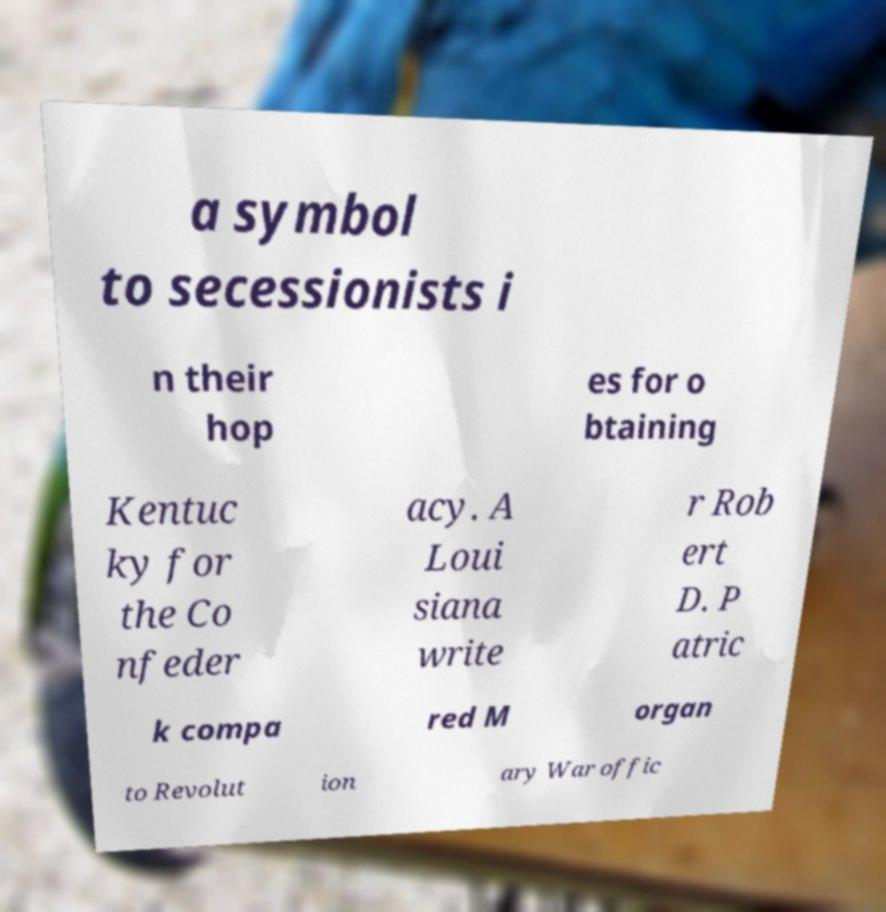Can you read and provide the text displayed in the image?This photo seems to have some interesting text. Can you extract and type it out for me? a symbol to secessionists i n their hop es for o btaining Kentuc ky for the Co nfeder acy. A Loui siana write r Rob ert D. P atric k compa red M organ to Revolut ion ary War offic 